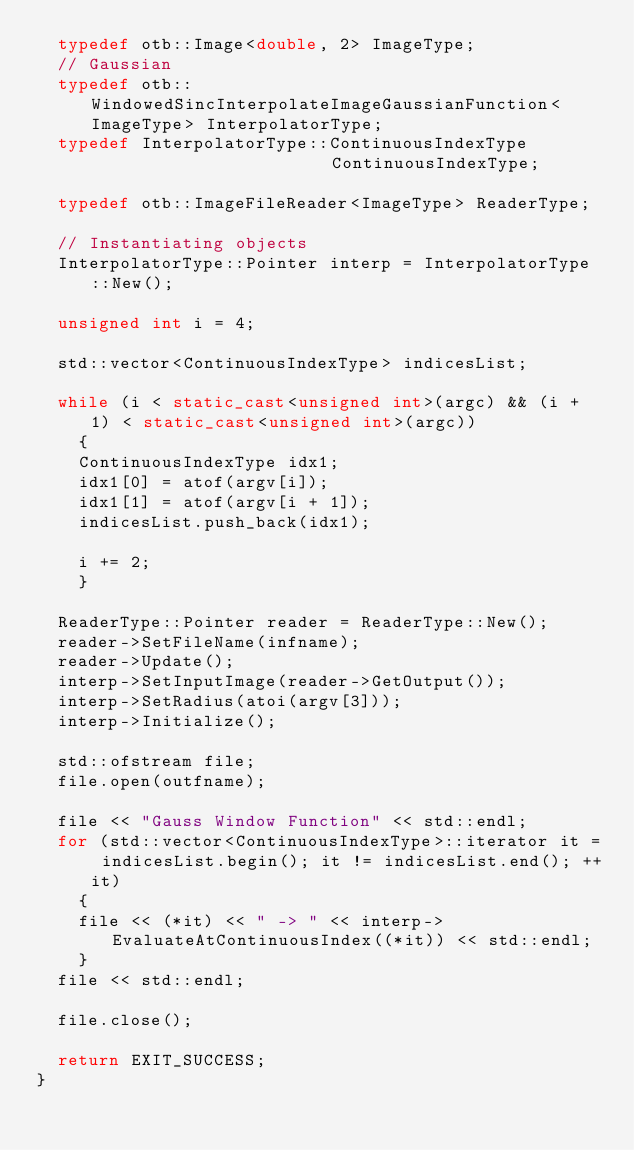<code> <loc_0><loc_0><loc_500><loc_500><_C++_>  typedef otb::Image<double, 2> ImageType;
  // Gaussian
  typedef otb::WindowedSincInterpolateImageGaussianFunction<ImageType> InterpolatorType;
  typedef InterpolatorType::ContinuousIndexType                        ContinuousIndexType;

  typedef otb::ImageFileReader<ImageType> ReaderType;

  // Instantiating objects
  InterpolatorType::Pointer interp = InterpolatorType::New();

  unsigned int i = 4;

  std::vector<ContinuousIndexType> indicesList;

  while (i < static_cast<unsigned int>(argc) && (i + 1) < static_cast<unsigned int>(argc))
    {
    ContinuousIndexType idx1;
    idx1[0] = atof(argv[i]);
    idx1[1] = atof(argv[i + 1]);
    indicesList.push_back(idx1);

    i += 2;
    }

  ReaderType::Pointer reader = ReaderType::New();
  reader->SetFileName(infname);
  reader->Update();
  interp->SetInputImage(reader->GetOutput());
  interp->SetRadius(atoi(argv[3]));
  interp->Initialize();

  std::ofstream file;
  file.open(outfname);

  file << "Gauss Window Function" << std::endl;
  for (std::vector<ContinuousIndexType>::iterator it = indicesList.begin(); it != indicesList.end(); ++it)
    {
    file << (*it) << " -> " << interp->EvaluateAtContinuousIndex((*it)) << std::endl;
    }
  file << std::endl;

  file.close();

  return EXIT_SUCCESS;
}
</code> 